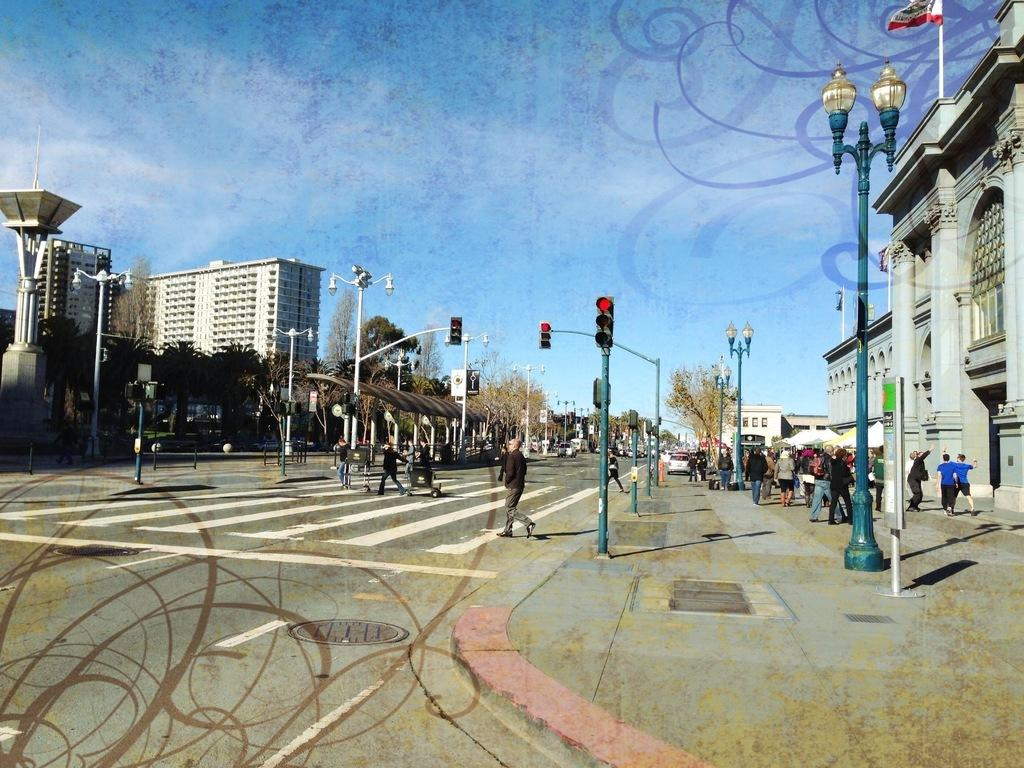What are the people in the image doing? The people in the image are standing on the footpath and road. What can be seen on the footpath besides people? There are street light poles on the footpath. What type of natural elements are present in the image? There are a lot of trees in the image. What can be seen in the distance in the image? There are buildings visible in the background. What type of tin can be seen being transported by a cart in the image? There is no tin or cart present in the image. What type of school can be seen in the image? There is no school present in the image. 